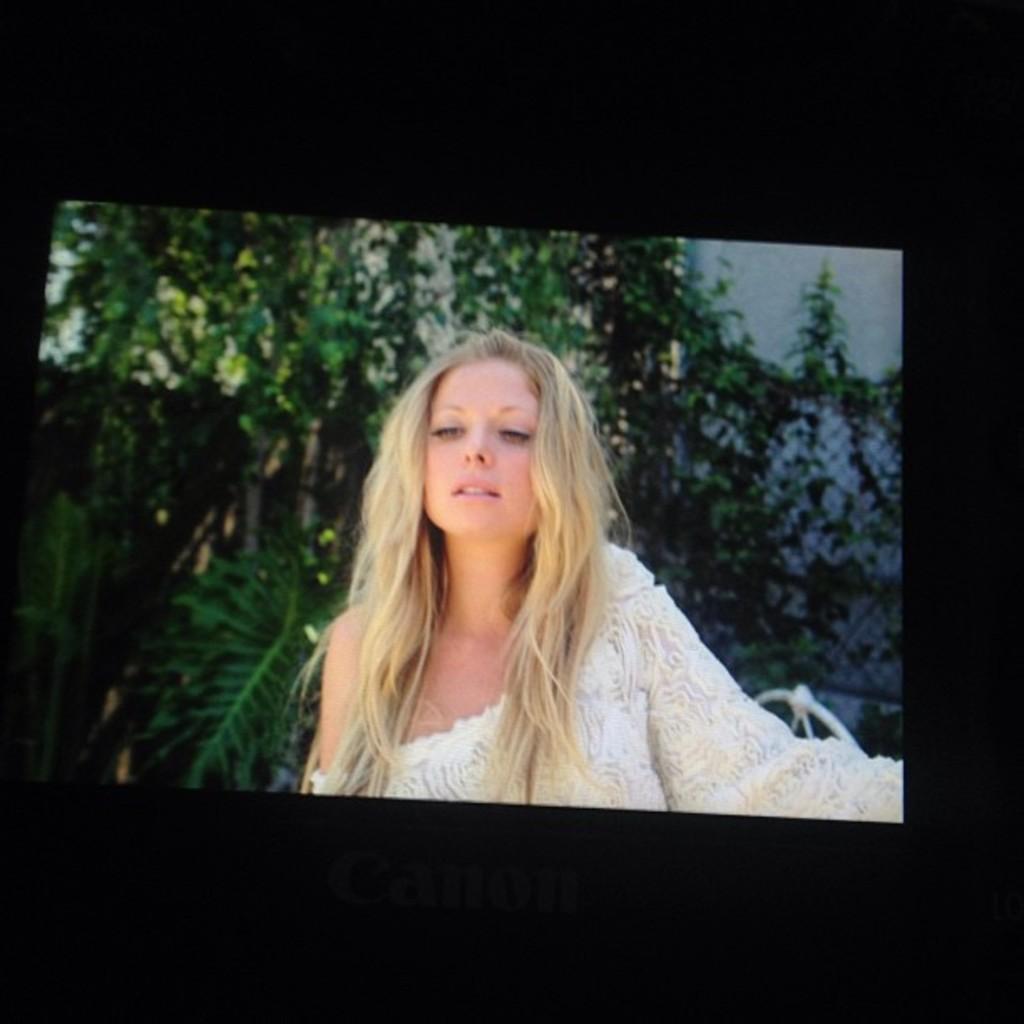Describe this image in one or two sentences. In this image we can see the picture of woman and trees on the camera screen. 